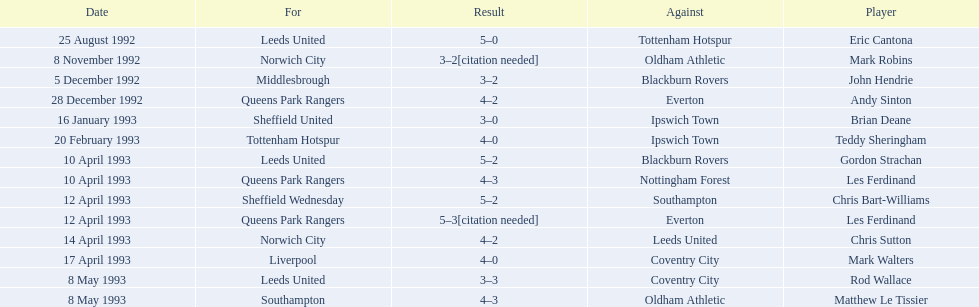Who are the players in 1992-93 fa premier league? Eric Cantona, Mark Robins, John Hendrie, Andy Sinton, Brian Deane, Teddy Sheringham, Gordon Strachan, Les Ferdinand, Chris Bart-Williams, Les Ferdinand, Chris Sutton, Mark Walters, Rod Wallace, Matthew Le Tissier. What is mark robins' result? 3–2[citation needed]. Which player has the same result? John Hendrie. 